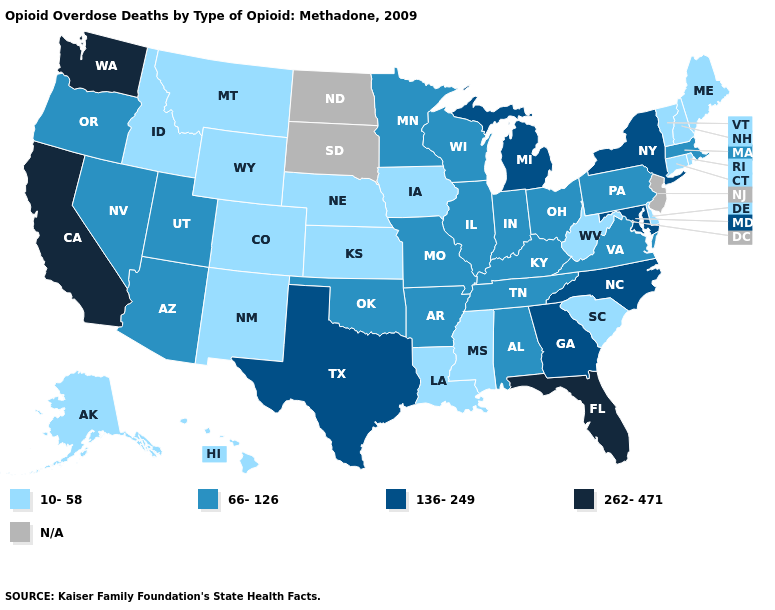What is the highest value in the USA?
Short answer required. 262-471. What is the lowest value in the USA?
Be succinct. 10-58. What is the value of Maryland?
Answer briefly. 136-249. What is the lowest value in the Northeast?
Give a very brief answer. 10-58. What is the highest value in the West ?
Keep it brief. 262-471. What is the value of South Dakota?
Give a very brief answer. N/A. What is the value of Idaho?
Keep it brief. 10-58. What is the value of South Dakota?
Keep it brief. N/A. What is the value of Alabama?
Answer briefly. 66-126. Does the map have missing data?
Quick response, please. Yes. What is the value of Ohio?
Quick response, please. 66-126. Among the states that border Massachusetts , does Vermont have the highest value?
Answer briefly. No. What is the value of California?
Write a very short answer. 262-471. What is the value of Georgia?
Answer briefly. 136-249. 